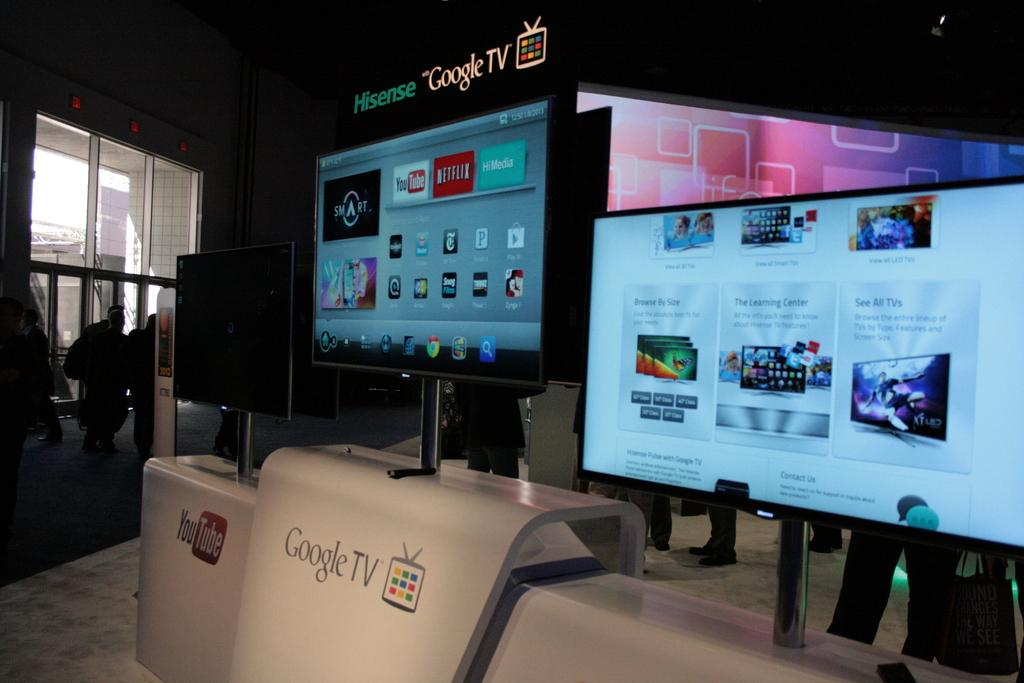<image>
Provide a brief description of the given image. Three screens are displayed horizontally sitting on stands to display ads for youtube and google. 